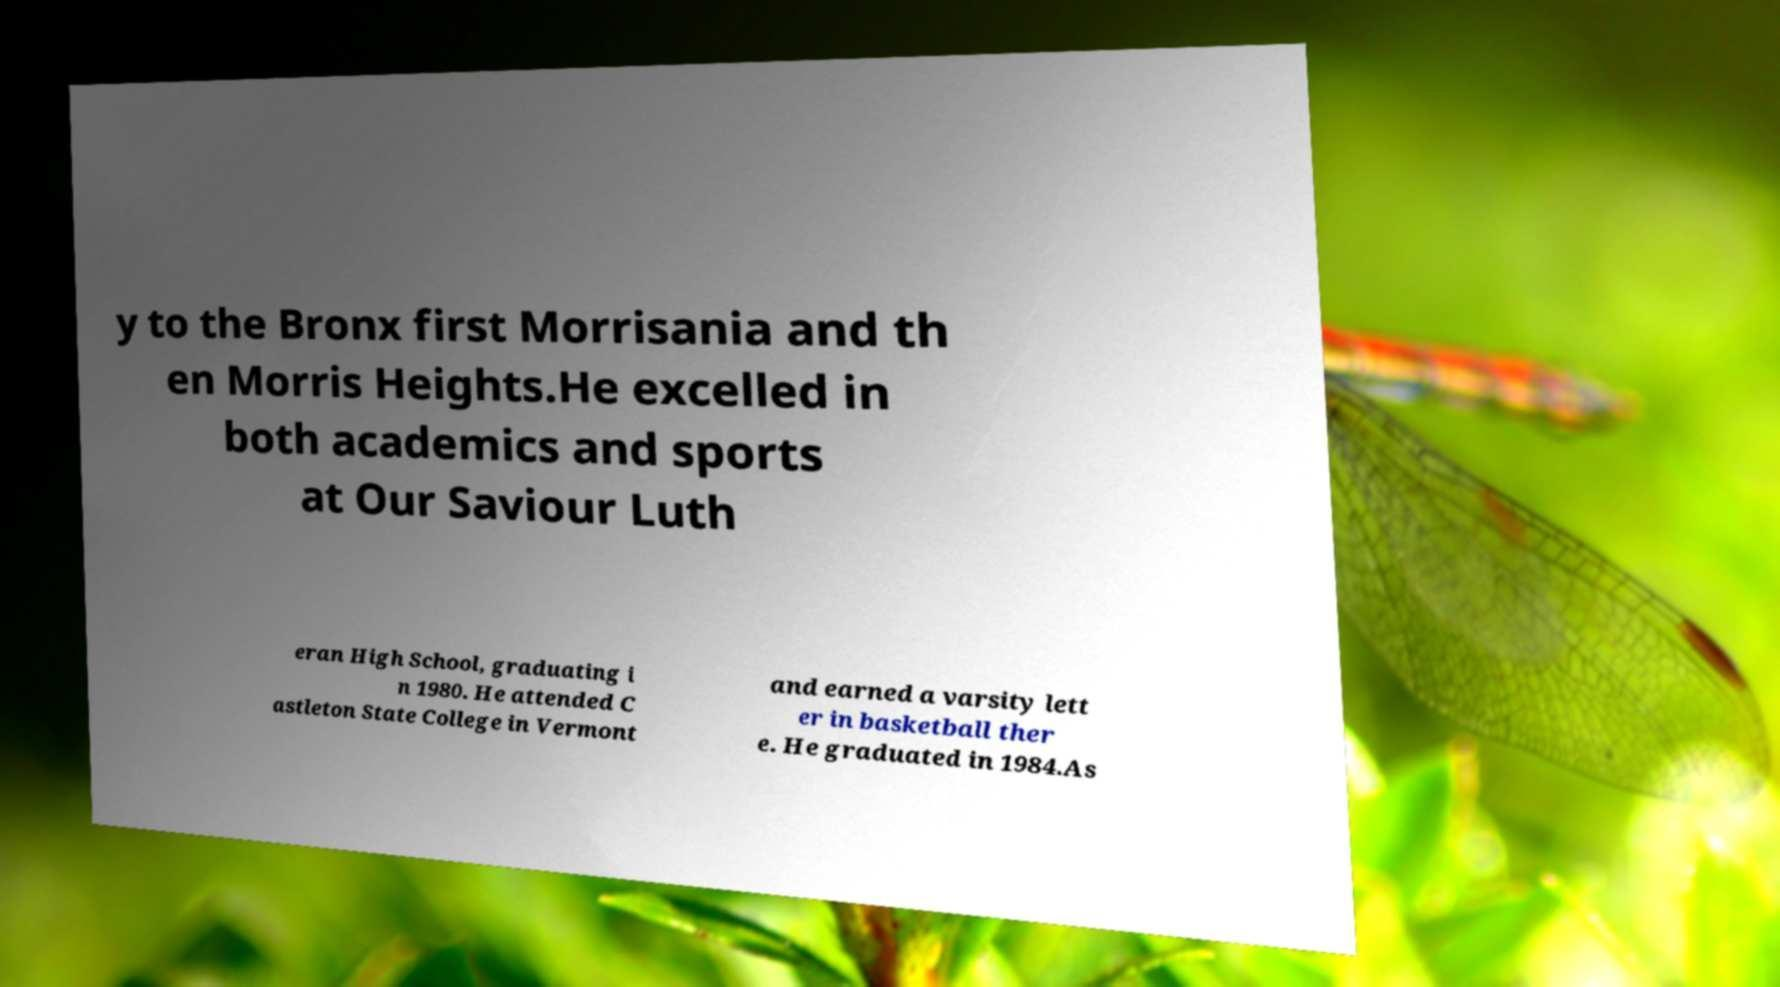I need the written content from this picture converted into text. Can you do that? y to the Bronx first Morrisania and th en Morris Heights.He excelled in both academics and sports at Our Saviour Luth eran High School, graduating i n 1980. He attended C astleton State College in Vermont and earned a varsity lett er in basketball ther e. He graduated in 1984.As 